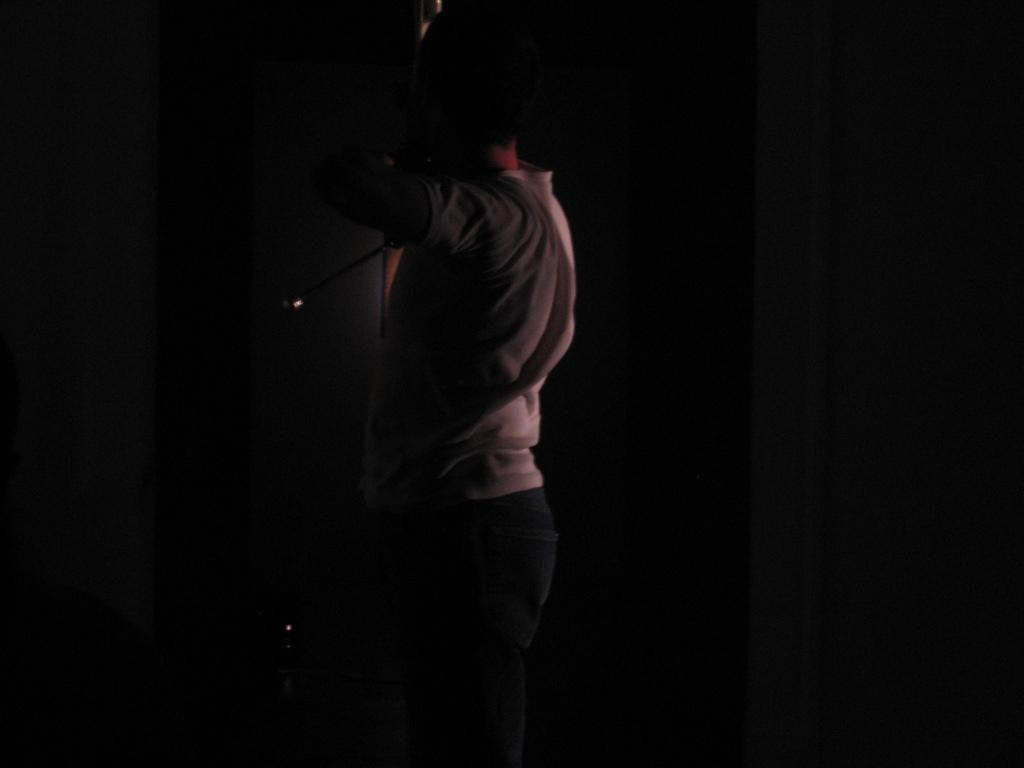How would you summarize this image in a sentence or two? As we can see in the image there is a person standing and the image is little dark. 